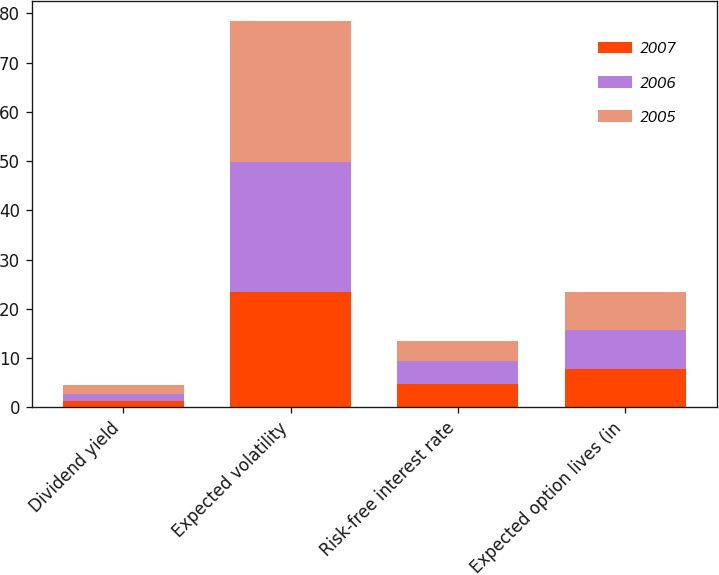Convert chart. <chart><loc_0><loc_0><loc_500><loc_500><stacked_bar_chart><ecel><fcel>Dividend yield<fcel>Expected volatility<fcel>Risk-free interest rate<fcel>Expected option lives (in<nl><fcel>2007<fcel>1.34<fcel>23.3<fcel>4.69<fcel>7.8<nl><fcel>2006<fcel>1.41<fcel>26.5<fcel>4.6<fcel>7.8<nl><fcel>2005<fcel>1.85<fcel>28.7<fcel>4.19<fcel>7.8<nl></chart> 